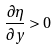<formula> <loc_0><loc_0><loc_500><loc_500>\frac { \partial \eta } { \partial y } > 0</formula> 